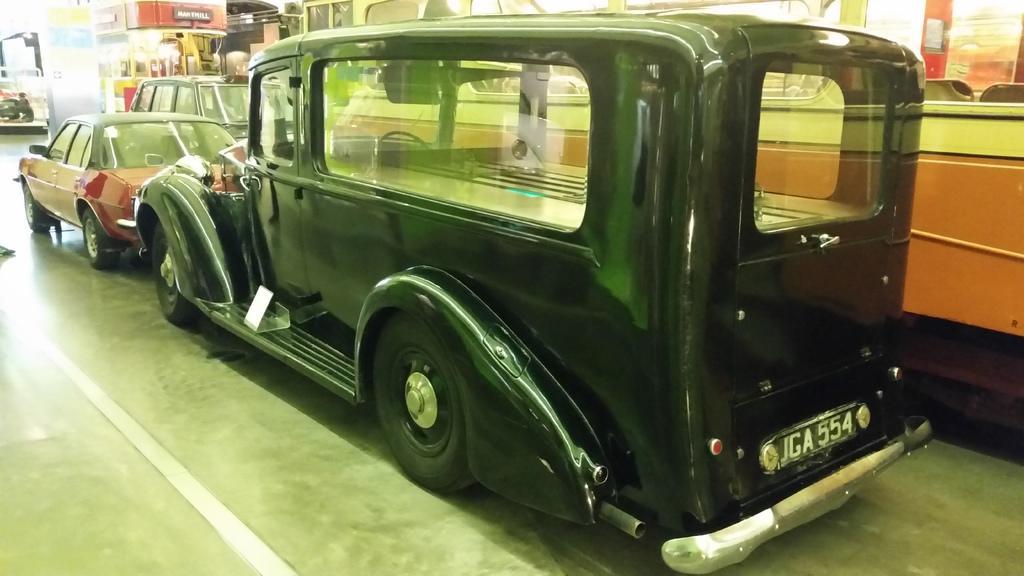Describe this image in one or two sentences. In the image there are different kinds of vehicles. In the background there is a pillar with posters. And there are some other things in the background. 